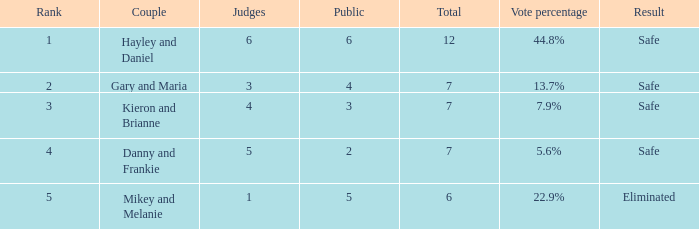What was the complete number when the vote proportion was 4 1.0. 